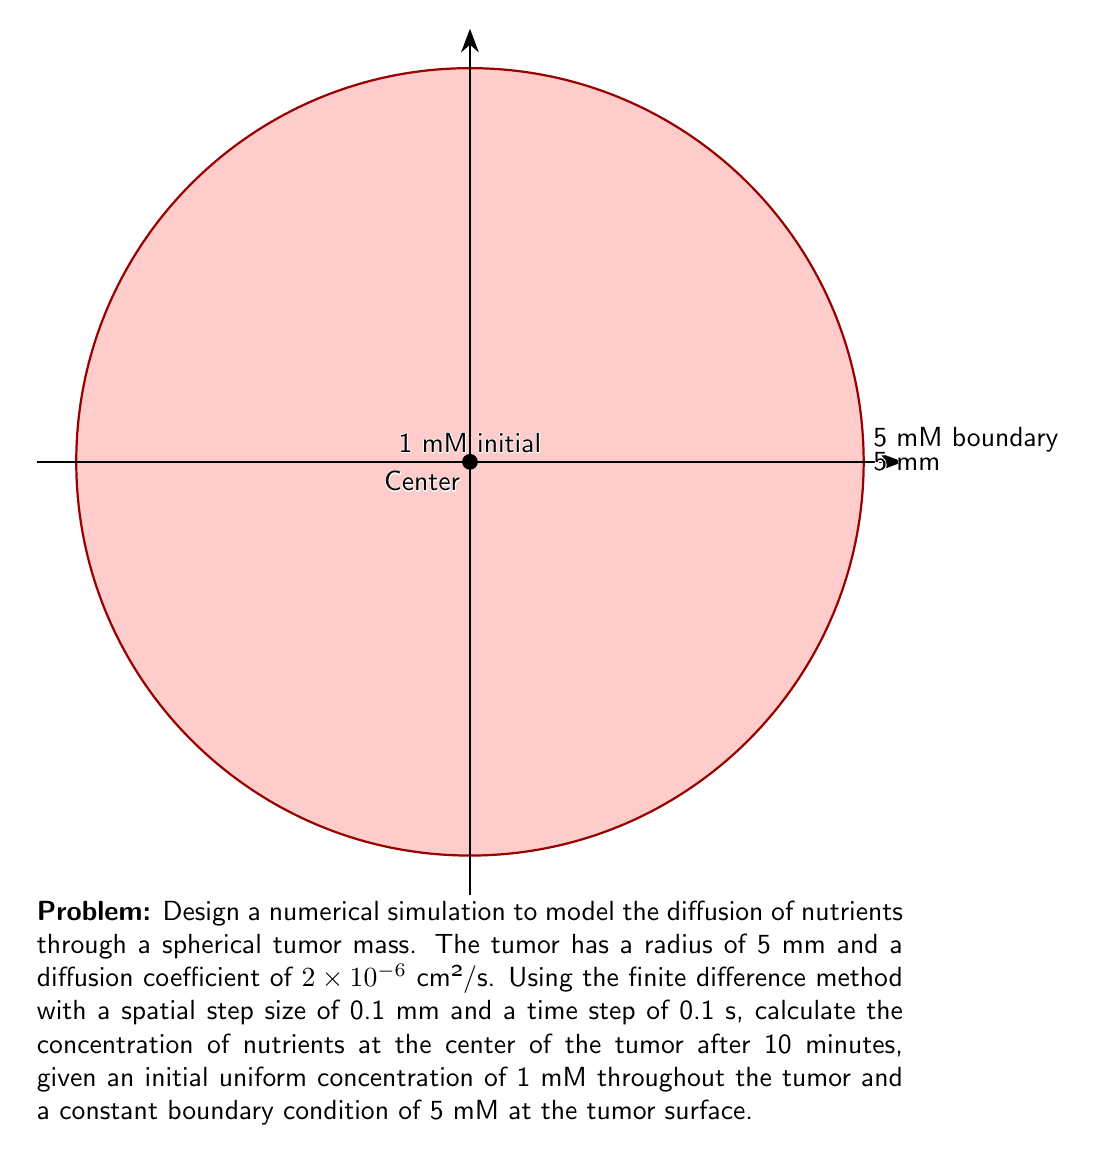Show me your answer to this math problem. To solve this problem, we'll use the finite difference method to approximate the diffusion equation in spherical coordinates. The steps are as follows:

1) The diffusion equation in spherical coordinates (assuming radial symmetry):

   $$\frac{\partial C}{\partial t} = D \left(\frac{\partial^2 C}{\partial r^2} + \frac{2}{r}\frac{\partial C}{\partial r}\right)$$

   where $C$ is concentration, $t$ is time, $D$ is the diffusion coefficient, and $r$ is the radial distance.

2) Discretize the equation using central difference for space and forward difference for time:

   $$\frac{C_{i}^{n+1} - C_{i}^n}{\Delta t} = D \left(\frac{C_{i+1}^n - 2C_{i}^n + C_{i-1}^n}{(\Delta r)^2} + \frac{2}{r_i}\frac{C_{i+1}^n - C_{i-1}^n}{2\Delta r}\right)$$

3) Rearrange to solve for $C_{i}^{n+1}$:

   $$C_{i}^{n+1} = C_{i}^n + \frac{D\Delta t}{(\Delta r)^2}\left(C_{i+1}^n - 2C_{i}^n + C_{i-1}^n + \frac{\Delta r}{r_i}(C_{i+1}^n - C_{i-1}^n)\right)$$

4) Given parameters:
   - $D = 2 \times 10^{-6}$ cm²/s = $2 \times 10^{-4}$ mm²/s
   - $\Delta r = 0.1$ mm
   - $\Delta t = 0.1$ s
   - Total time = 10 minutes = 600 s
   - Number of time steps = 600 / 0.1 = 6000
   - Number of spatial steps = 5 / 0.1 = 50

5) Implement the numerical scheme:
   - Initialize $C_{i}^0 = 1$ mM for all $i$
   - Set boundary condition $C_{50}^n = 5$ mM for all $n$
   - Use the finite difference equation to update concentrations
   - Repeat for 6000 time steps

6) After the simulation, the concentration at the center ($i = 0$) gives the required answer.

Note: The actual implementation would require a computer program to perform these calculations efficiently.
Answer: $\approx 3.2$ mM 